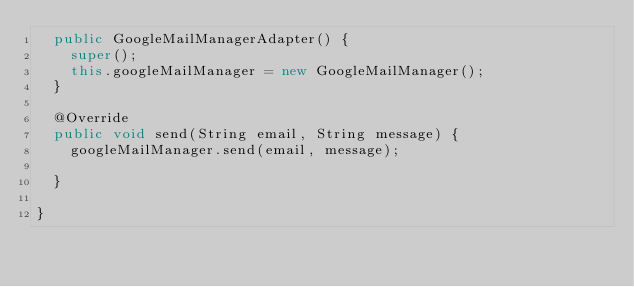<code> <loc_0><loc_0><loc_500><loc_500><_Java_>	public GoogleMailManagerAdapter() {
		super();
		this.googleMailManager = new GoogleMailManager();
	}

	@Override
	public void send(String email, String message) {
		googleMailManager.send(email, message);

	}

}
</code> 